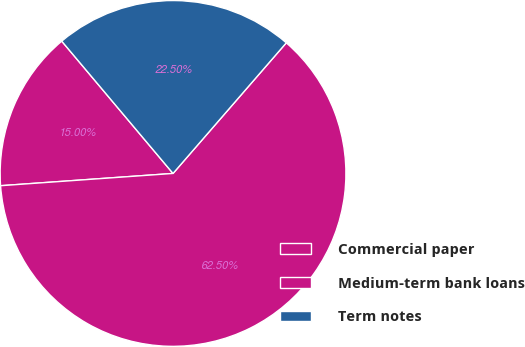Convert chart. <chart><loc_0><loc_0><loc_500><loc_500><pie_chart><fcel>Commercial paper<fcel>Medium-term bank loans<fcel>Term notes<nl><fcel>15.0%<fcel>62.5%<fcel>22.5%<nl></chart> 